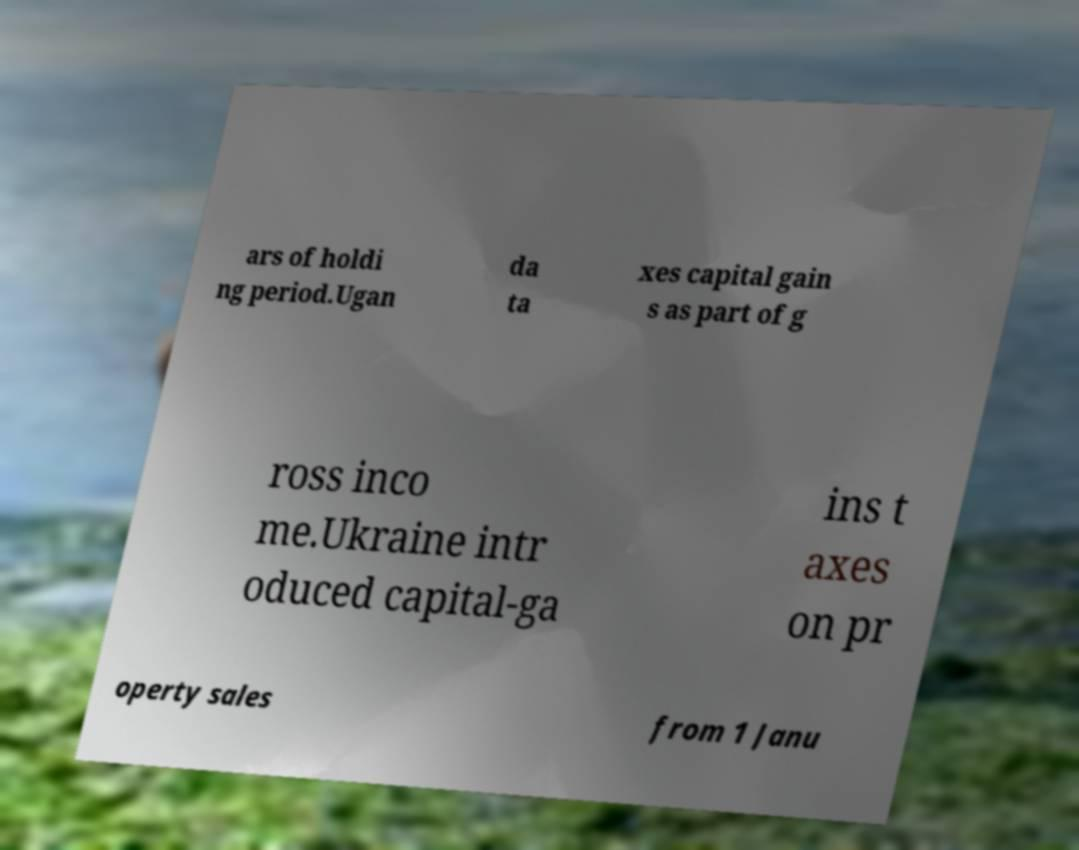What messages or text are displayed in this image? I need them in a readable, typed format. ars of holdi ng period.Ugan da ta xes capital gain s as part of g ross inco me.Ukraine intr oduced capital-ga ins t axes on pr operty sales from 1 Janu 